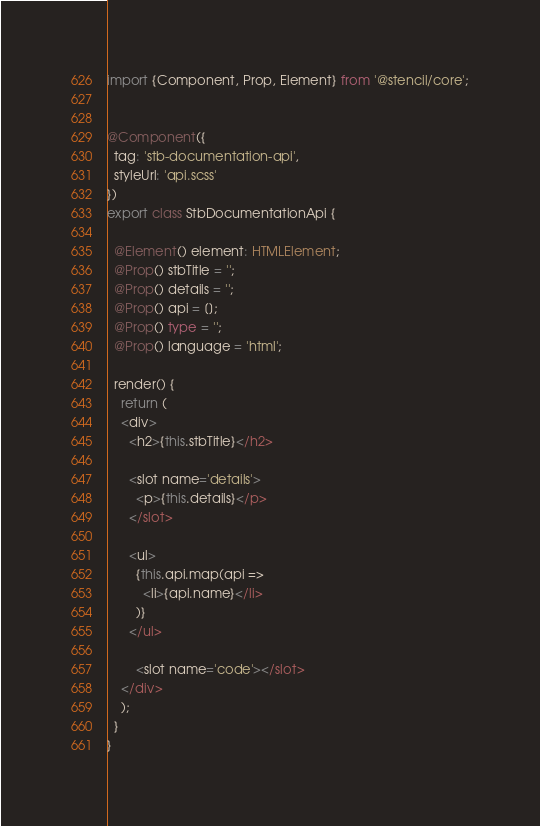<code> <loc_0><loc_0><loc_500><loc_500><_TypeScript_>import {Component, Prop, Element} from '@stencil/core';


@Component({
  tag: 'stb-documentation-api',
  styleUrl: 'api.scss'
})
export class StbDocumentationApi {

  @Element() element: HTMLElement;
  @Prop() stbTitle = '';
  @Prop() details = '';
  @Prop() api = [];
  @Prop() type = '';
  @Prop() language = 'html';

  render() {
    return (
    <div>
      <h2>{this.stbTitle}</h2>

      <slot name='details'>
        <p>{this.details}</p>
      </slot>

      <ul>
        {this.api.map(api =>
          <li>{api.name}</li>
        )}
      </ul>

        <slot name='code'></slot>
    </div>
    );
  }
}
</code> 